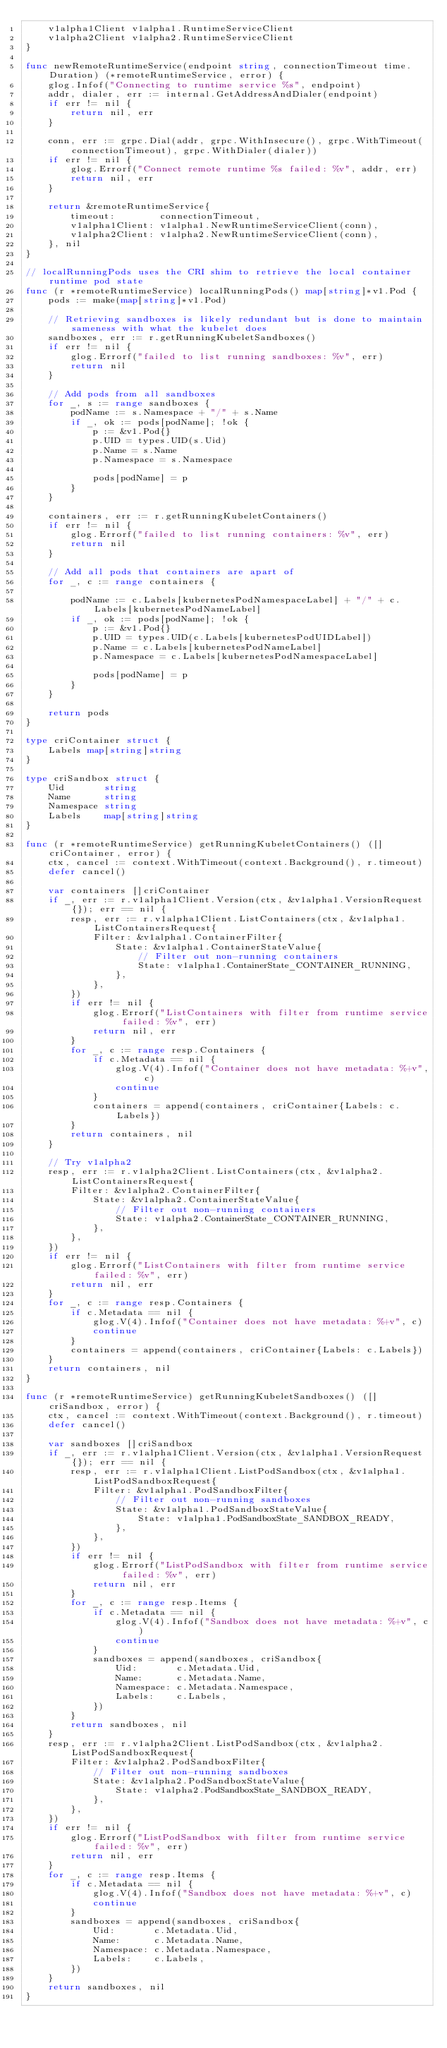<code> <loc_0><loc_0><loc_500><loc_500><_Go_>	v1alpha1Client v1alpha1.RuntimeServiceClient
	v1alpha2Client v1alpha2.RuntimeServiceClient
}

func newRemoteRuntimeService(endpoint string, connectionTimeout time.Duration) (*remoteRuntimeService, error) {
	glog.Infof("Connecting to runtime service %s", endpoint)
	addr, dialer, err := internal.GetAddressAndDialer(endpoint)
	if err != nil {
		return nil, err
	}

	conn, err := grpc.Dial(addr, grpc.WithInsecure(), grpc.WithTimeout(connectionTimeout), grpc.WithDialer(dialer))
	if err != nil {
		glog.Errorf("Connect remote runtime %s failed: %v", addr, err)
		return nil, err
	}

	return &remoteRuntimeService{
		timeout:        connectionTimeout,
		v1alpha1Client: v1alpha1.NewRuntimeServiceClient(conn),
		v1alpha2Client: v1alpha2.NewRuntimeServiceClient(conn),
	}, nil
}

// localRunningPods uses the CRI shim to retrieve the local container runtime pod state
func (r *remoteRuntimeService) localRunningPods() map[string]*v1.Pod {
	pods := make(map[string]*v1.Pod)

	// Retrieving sandboxes is likely redundant but is done to maintain sameness with what the kubelet does
	sandboxes, err := r.getRunningKubeletSandboxes()
	if err != nil {
		glog.Errorf("failed to list running sandboxes: %v", err)
		return nil
	}

	// Add pods from all sandboxes
	for _, s := range sandboxes {
		podName := s.Namespace + "/" + s.Name
		if _, ok := pods[podName]; !ok {
			p := &v1.Pod{}
			p.UID = types.UID(s.Uid)
			p.Name = s.Name
			p.Namespace = s.Namespace

			pods[podName] = p
		}
	}

	containers, err := r.getRunningKubeletContainers()
	if err != nil {
		glog.Errorf("failed to list running containers: %v", err)
		return nil
	}

	// Add all pods that containers are apart of
	for _, c := range containers {

		podName := c.Labels[kubernetesPodNamespaceLabel] + "/" + c.Labels[kubernetesPodNameLabel]
		if _, ok := pods[podName]; !ok {
			p := &v1.Pod{}
			p.UID = types.UID(c.Labels[kubernetesPodUIDLabel])
			p.Name = c.Labels[kubernetesPodNameLabel]
			p.Namespace = c.Labels[kubernetesPodNamespaceLabel]

			pods[podName] = p
		}
	}

	return pods
}

type criContainer struct {
	Labels map[string]string
}

type criSandbox struct {
	Uid       string
	Name      string
	Namespace string
	Labels    map[string]string
}

func (r *remoteRuntimeService) getRunningKubeletContainers() ([]criContainer, error) {
	ctx, cancel := context.WithTimeout(context.Background(), r.timeout)
	defer cancel()

	var containers []criContainer
	if _, err := r.v1alpha1Client.Version(ctx, &v1alpha1.VersionRequest{}); err == nil {
		resp, err := r.v1alpha1Client.ListContainers(ctx, &v1alpha1.ListContainersRequest{
			Filter: &v1alpha1.ContainerFilter{
				State: &v1alpha1.ContainerStateValue{
					// Filter out non-running containers
					State: v1alpha1.ContainerState_CONTAINER_RUNNING,
				},
			},
		})
		if err != nil {
			glog.Errorf("ListContainers with filter from runtime service failed: %v", err)
			return nil, err
		}
		for _, c := range resp.Containers {
			if c.Metadata == nil {
				glog.V(4).Infof("Container does not have metadata: %+v", c)
				continue
			}
			containers = append(containers, criContainer{Labels: c.Labels})
		}
		return containers, nil
	}

	// Try v1alpha2
	resp, err := r.v1alpha2Client.ListContainers(ctx, &v1alpha2.ListContainersRequest{
		Filter: &v1alpha2.ContainerFilter{
			State: &v1alpha2.ContainerStateValue{
				// Filter out non-running containers
				State: v1alpha2.ContainerState_CONTAINER_RUNNING,
			},
		},
	})
	if err != nil {
		glog.Errorf("ListContainers with filter from runtime service failed: %v", err)
		return nil, err
	}
	for _, c := range resp.Containers {
		if c.Metadata == nil {
			glog.V(4).Infof("Container does not have metadata: %+v", c)
			continue
		}
		containers = append(containers, criContainer{Labels: c.Labels})
	}
	return containers, nil
}

func (r *remoteRuntimeService) getRunningKubeletSandboxes() ([]criSandbox, error) {
	ctx, cancel := context.WithTimeout(context.Background(), r.timeout)
	defer cancel()

	var sandboxes []criSandbox
	if _, err := r.v1alpha1Client.Version(ctx, &v1alpha1.VersionRequest{}); err == nil {
		resp, err := r.v1alpha1Client.ListPodSandbox(ctx, &v1alpha1.ListPodSandboxRequest{
			Filter: &v1alpha1.PodSandboxFilter{
				// Filter out non-running sandboxes
				State: &v1alpha1.PodSandboxStateValue{
					State: v1alpha1.PodSandboxState_SANDBOX_READY,
				},
			},
		})
		if err != nil {
			glog.Errorf("ListPodSandbox with filter from runtime service failed: %v", err)
			return nil, err
		}
		for _, c := range resp.Items {
			if c.Metadata == nil {
				glog.V(4).Infof("Sandbox does not have metadata: %+v", c)
				continue
			}
			sandboxes = append(sandboxes, criSandbox{
				Uid:       c.Metadata.Uid,
				Name:      c.Metadata.Name,
				Namespace: c.Metadata.Namespace,
				Labels:    c.Labels,
			})
		}
		return sandboxes, nil
	}
	resp, err := r.v1alpha2Client.ListPodSandbox(ctx, &v1alpha2.ListPodSandboxRequest{
		Filter: &v1alpha2.PodSandboxFilter{
			// Filter out non-running sandboxes
			State: &v1alpha2.PodSandboxStateValue{
				State: v1alpha2.PodSandboxState_SANDBOX_READY,
			},
		},
	})
	if err != nil {
		glog.Errorf("ListPodSandbox with filter from runtime service failed: %v", err)
		return nil, err
	}
	for _, c := range resp.Items {
		if c.Metadata == nil {
			glog.V(4).Infof("Sandbox does not have metadata: %+v", c)
			continue
		}
		sandboxes = append(sandboxes, criSandbox{
			Uid:       c.Metadata.Uid,
			Name:      c.Metadata.Name,
			Namespace: c.Metadata.Namespace,
			Labels:    c.Labels,
		})
	}
	return sandboxes, nil
}
</code> 